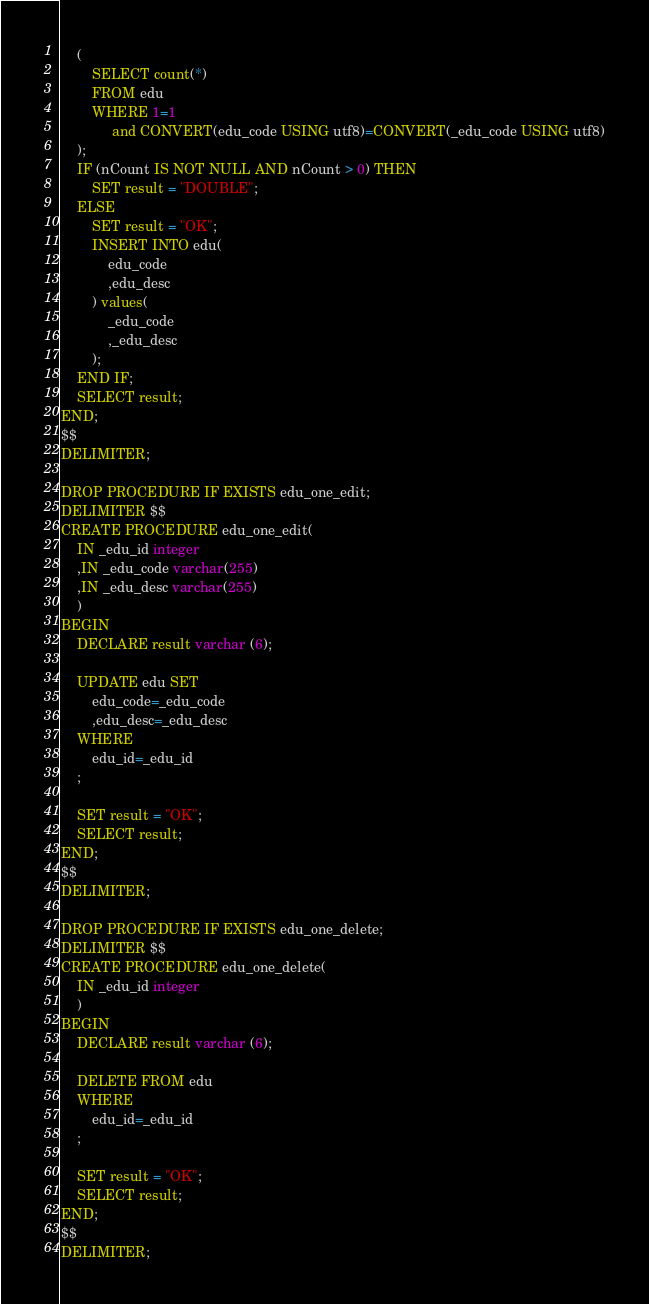<code> <loc_0><loc_0><loc_500><loc_500><_SQL_>    (
		SELECT count(*)
		FROM edu
		WHERE 1=1
			 and CONVERT(edu_code USING utf8)=CONVERT(_edu_code USING utf8)
    );
	IF (nCount IS NOT NULL AND nCount > 0) THEN
		SET result = "DOUBLE";
	ELSE
		SET result = "OK";
		INSERT INTO edu(
			edu_code
			,edu_desc
		) values(
			_edu_code
			,_edu_desc
		);
	END IF;
	SELECT result;
END;
$$
DELIMITER;

DROP PROCEDURE IF EXISTS edu_one_edit;
DELIMITER $$
CREATE PROCEDURE edu_one_edit(
	IN _edu_id integer
	,IN _edu_code varchar(255)
	,IN _edu_desc varchar(255)
	)
BEGIN
	DECLARE result varchar (6);

	UPDATE edu SET
		edu_code=_edu_code
		,edu_desc=_edu_desc
	WHERE 
		edu_id=_edu_id
	;

	SET result = "OK";
	SELECT result;
END;
$$
DELIMITER;

DROP PROCEDURE IF EXISTS edu_one_delete;
DELIMITER $$
CREATE PROCEDURE edu_one_delete(
	IN _edu_id integer
	)
BEGIN
	DECLARE result varchar (6);

	DELETE FROM edu
	WHERE 
		edu_id=_edu_id
	;

	SET result = "OK";
	SELECT result;
END;
$$
DELIMITER;




</code> 